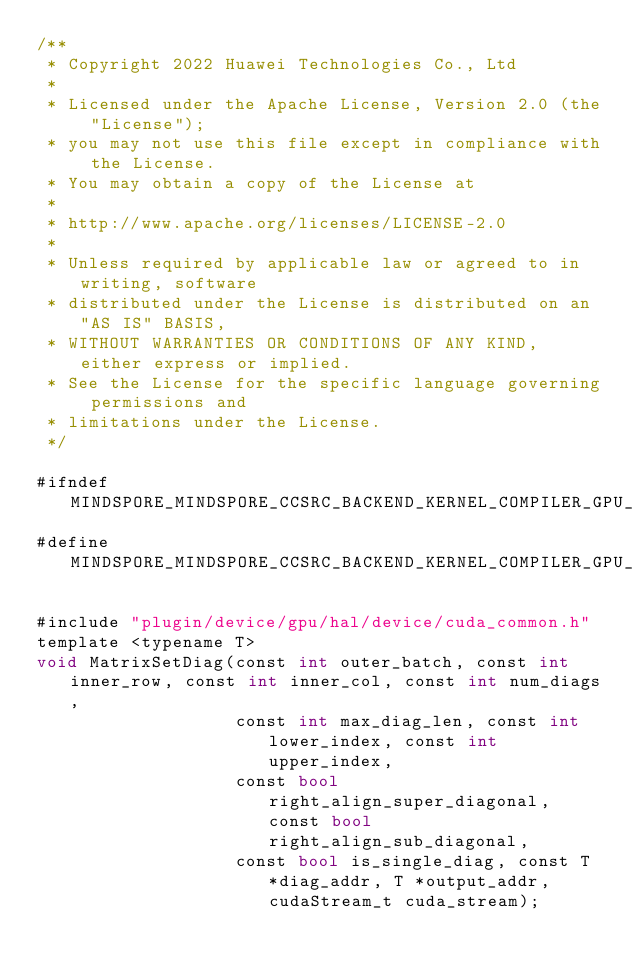<code> <loc_0><loc_0><loc_500><loc_500><_Cuda_>/**
 * Copyright 2022 Huawei Technologies Co., Ltd
 *
 * Licensed under the Apache License, Version 2.0 (the "License");
 * you may not use this file except in compliance with the License.
 * You may obtain a copy of the License at
 *
 * http://www.apache.org/licenses/LICENSE-2.0
 *
 * Unless required by applicable law or agreed to in writing, software
 * distributed under the License is distributed on an "AS IS" BASIS,
 * WITHOUT WARRANTIES OR CONDITIONS OF ANY KIND, either express or implied.
 * See the License for the specific language governing permissions and
 * limitations under the License.
 */

#ifndef MINDSPORE_MINDSPORE_CCSRC_BACKEND_KERNEL_COMPILER_GPU_CUDA_IMPL_MATRIX_SET_DIAG_IMPL_CUH_
#define MINDSPORE_MINDSPORE_CCSRC_BACKEND_KERNEL_COMPILER_GPU_CUDA_IMPL_MATRIX_SET_DIAG_IMPL_CUH_

#include "plugin/device/gpu/hal/device/cuda_common.h"
template <typename T>
void MatrixSetDiag(const int outer_batch, const int inner_row, const int inner_col, const int num_diags,
                   const int max_diag_len, const int lower_index, const int upper_index,
                   const bool right_align_super_diagonal, const bool right_align_sub_diagonal,
                   const bool is_single_diag, const T *diag_addr, T *output_addr, cudaStream_t cuda_stream);
</code> 